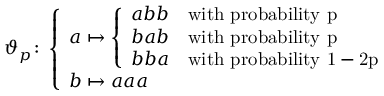Convert formula to latex. <formula><loc_0><loc_0><loc_500><loc_500>\vartheta _ { p } \colon \left \{ \begin{array} { l l } { a \mapsto \left \{ \begin{array} { l l } { a b b } & { w i t h p r o b a b i l i t y p } \\ { b a b } & { w i t h p r o b a b i l i t y p } \\ { b b a } & { w i t h p r o b a b i l i t y 1 - 2 p } \end{array} } \\ { b \mapsto a a a } \end{array}</formula> 